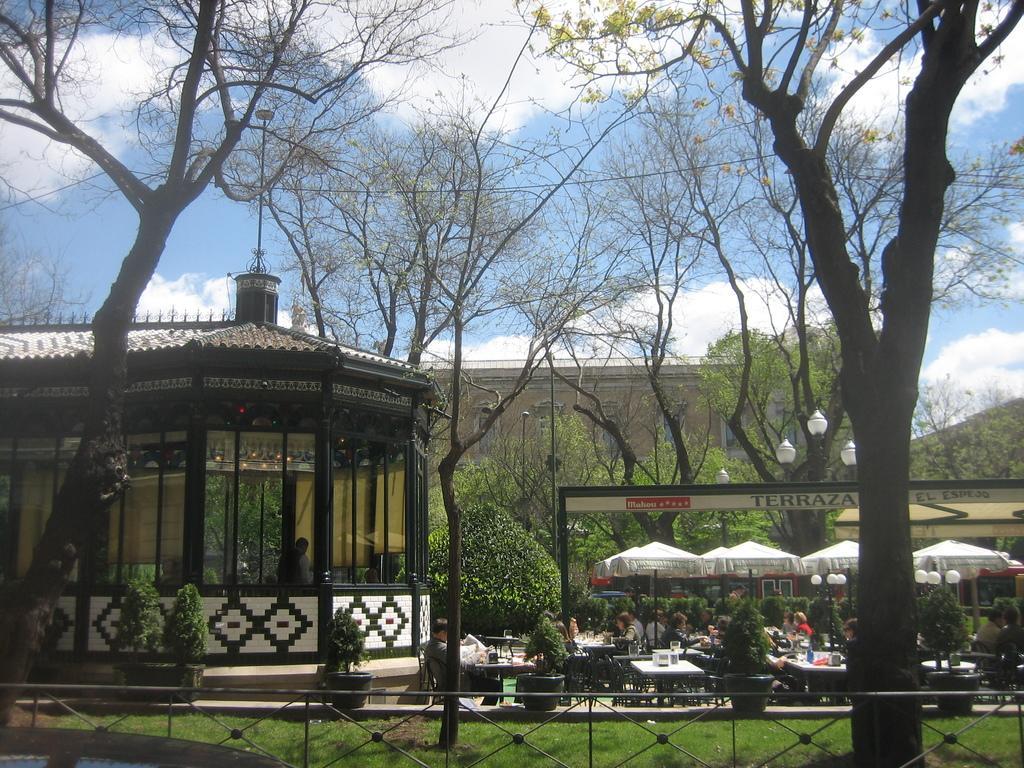Describe this image in one or two sentences. In this image I can see the iron fence and grass on the bottom side of the image. I can also see few buildings, number of trees, few poles, few lights, few white colour things and number of people. I can also see number of tables and on it I can see number of stuffs. In the background I can see clouds and the sky. In the center of the image I can see something is written on a thing and on the top side I can see a wire. 